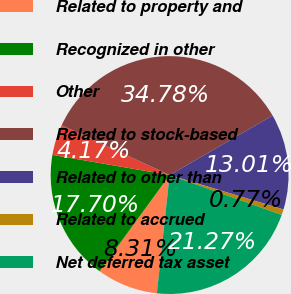<chart> <loc_0><loc_0><loc_500><loc_500><pie_chart><fcel>Related to property and<fcel>Recognized in other<fcel>Other<fcel>Related to stock-based<fcel>Related to other than<fcel>Related to accrued<fcel>Net deferred tax asset<nl><fcel>8.31%<fcel>17.7%<fcel>4.17%<fcel>34.78%<fcel>13.01%<fcel>0.77%<fcel>21.27%<nl></chart> 